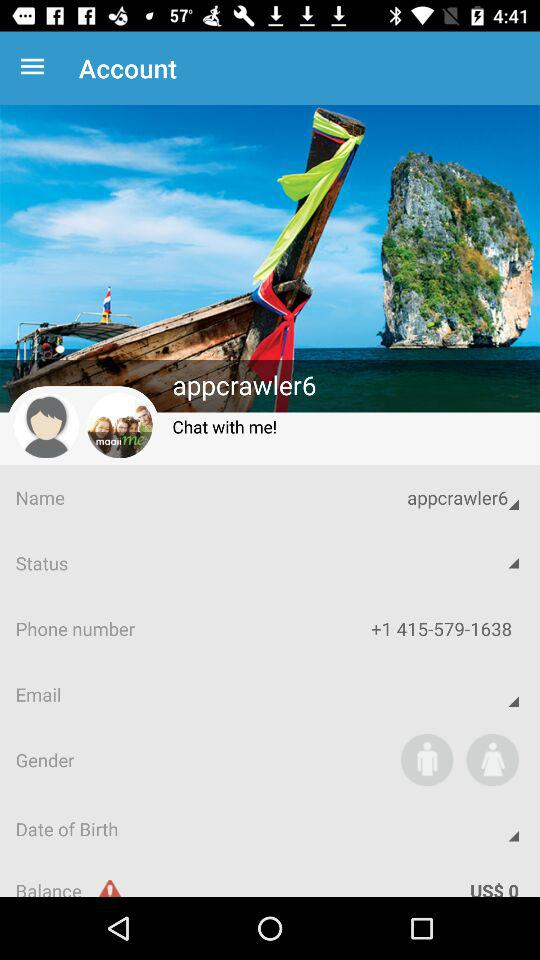What is the username? The username is "appcrawler6". 